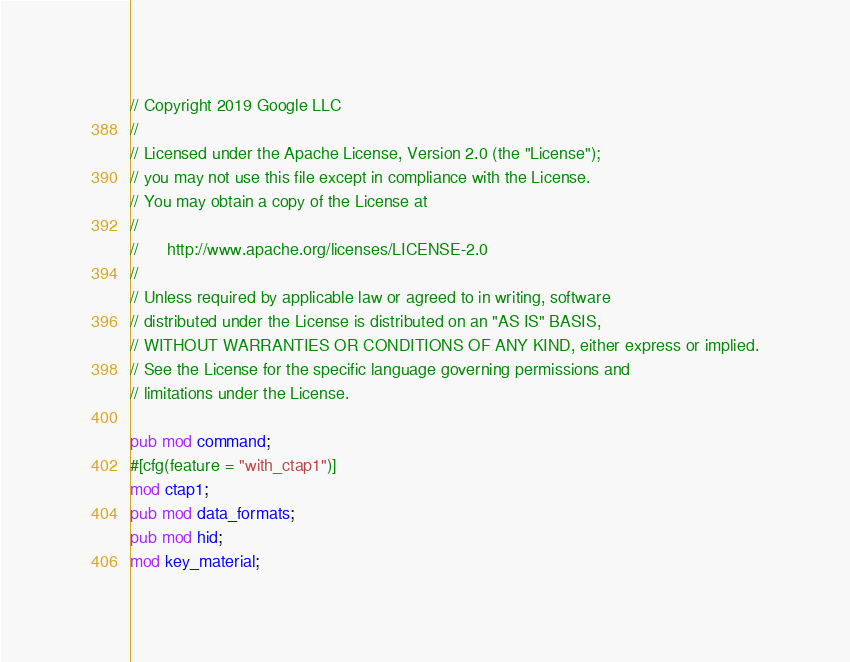<code> <loc_0><loc_0><loc_500><loc_500><_Rust_>// Copyright 2019 Google LLC
//
// Licensed under the Apache License, Version 2.0 (the "License");
// you may not use this file except in compliance with the License.
// You may obtain a copy of the License at
//
//      http://www.apache.org/licenses/LICENSE-2.0
//
// Unless required by applicable law or agreed to in writing, software
// distributed under the License is distributed on an "AS IS" BASIS,
// WITHOUT WARRANTIES OR CONDITIONS OF ANY KIND, either express or implied.
// See the License for the specific language governing permissions and
// limitations under the License.

pub mod command;
#[cfg(feature = "with_ctap1")]
mod ctap1;
pub mod data_formats;
pub mod hid;
mod key_material;</code> 